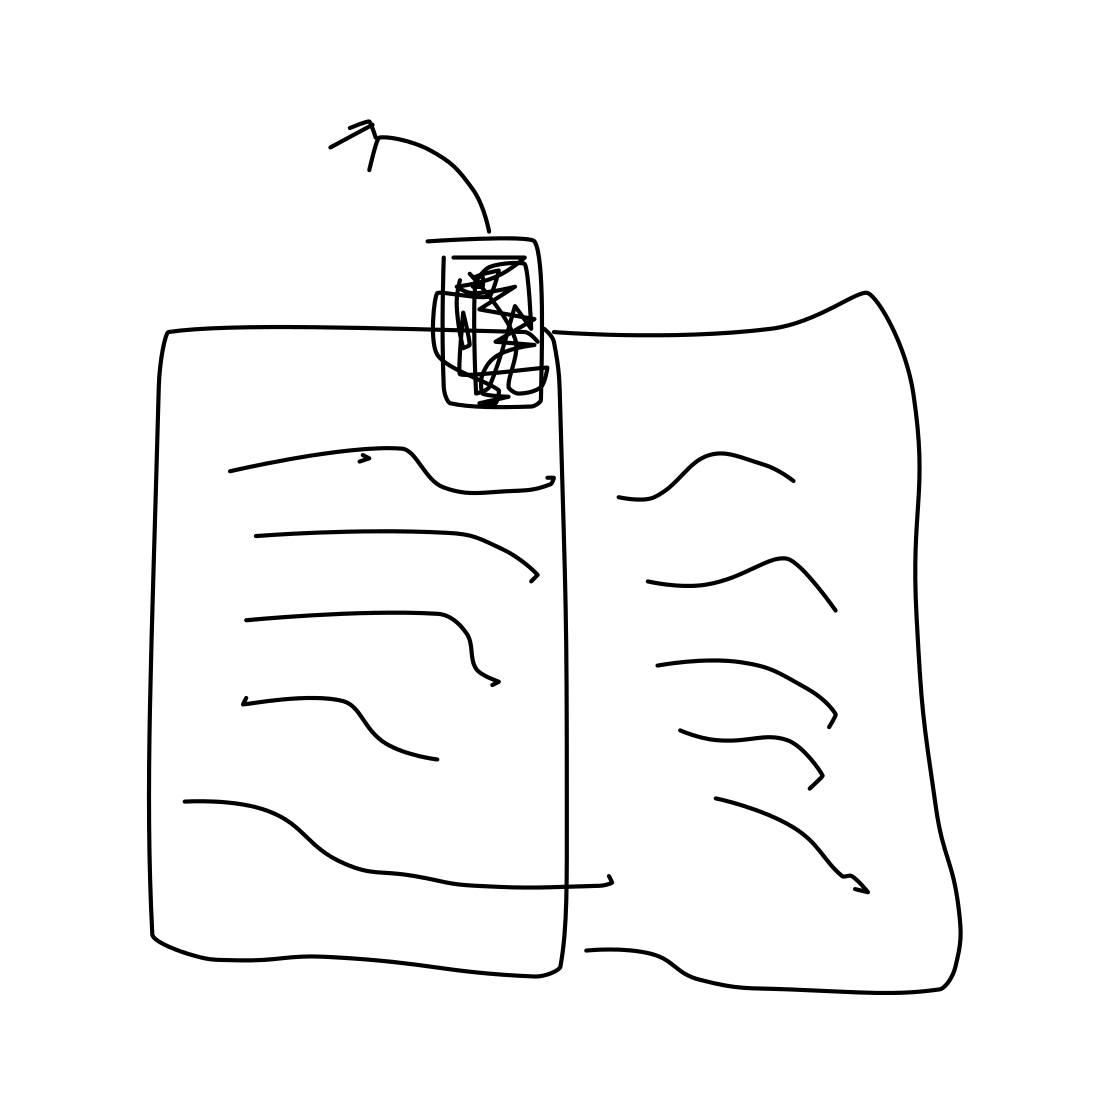Is there anything else of interest in the image, besides the book? The image is minimalistic, primarily focusing on the open book. The absence of other objects makes it difficult to ascertain more about the environment or context. It maintains attention on the book, opening a wide range of interpretation for the viewer. 